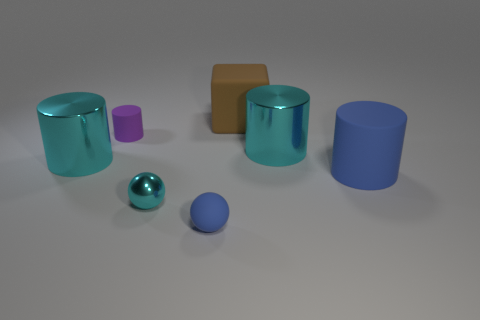Is the material of the tiny purple object the same as the brown cube?
Offer a terse response. Yes. Are there any other things that are the same shape as the large brown rubber thing?
Offer a terse response. No. There is a large cyan cylinder on the right side of the rubber cylinder that is left of the brown block; what is its material?
Ensure brevity in your answer.  Metal. What is the size of the thing behind the purple cylinder?
Keep it short and to the point. Large. There is a cylinder that is both behind the big matte cylinder and to the right of the big brown matte object; what color is it?
Ensure brevity in your answer.  Cyan. There is a metal sphere to the left of the brown rubber cube; does it have the same size as the small blue rubber ball?
Your response must be concise. Yes. There is a rubber object that is to the right of the brown rubber thing; is there a blue rubber sphere left of it?
Keep it short and to the point. Yes. What is the purple object made of?
Your answer should be compact. Rubber. Are there any shiny objects left of the brown rubber cube?
Provide a succinct answer. Yes. There is a purple object that is the same shape as the large blue matte object; what size is it?
Offer a very short reply. Small. 